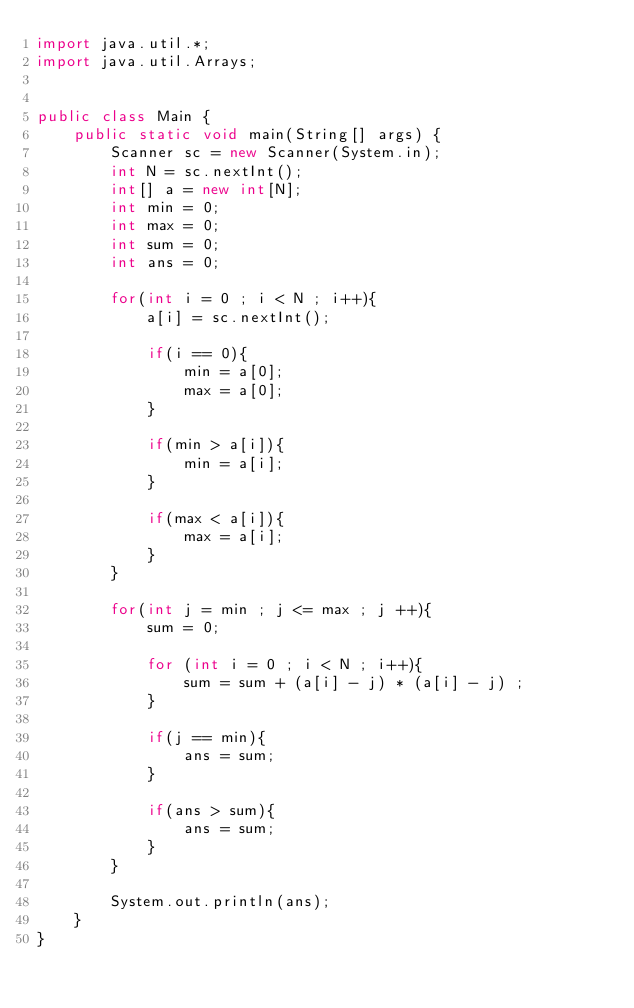Convert code to text. <code><loc_0><loc_0><loc_500><loc_500><_Java_>import java.util.*;
import java.util.Arrays;


public class Main {
    public static void main(String[] args) {
        Scanner sc = new Scanner(System.in);
        int N = sc.nextInt();
        int[] a = new int[N];
        int min = 0;
        int max = 0;
        int sum = 0;
        int ans = 0;

        for(int i = 0 ; i < N ; i++){
            a[i] = sc.nextInt();

            if(i == 0){
                min = a[0];
                max = a[0];
            }

            if(min > a[i]){
                min = a[i];
            }

            if(max < a[i]){
                max = a[i];
            }
        }

        for(int j = min ; j <= max ; j ++){
            sum = 0;
            
            for (int i = 0 ; i < N ; i++){
                sum = sum + (a[i] - j) * (a[i] - j) ;
            }

            if(j == min){
                ans = sum;
            }

            if(ans > sum){
                ans = sum;
            }
        }

        System.out.println(ans);
    }
}</code> 